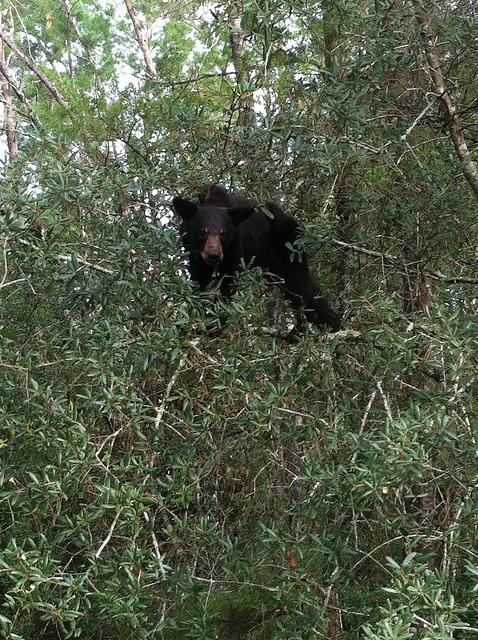Does the bear look like he's going to fall?
Give a very brief answer. No. What is this animal?
Short answer required. Bear. Is this a house cat?
Short answer required. No. What kind of bear is this?
Concise answer only. Black. Does the bear look relaxed?
Be succinct. No. Is he big for his species?
Write a very short answer. No. 